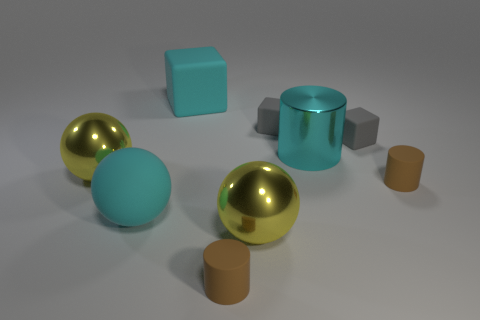The big cylinder has what color?
Offer a terse response. Cyan. There is a large cyan shiny object; are there any tiny brown rubber cylinders in front of it?
Offer a very short reply. Yes. There is a big block that is the same color as the large metallic cylinder; what is its material?
Your response must be concise. Rubber. Do the cyan sphere and the cyan metallic object that is in front of the large cube have the same size?
Provide a short and direct response. Yes. Is there a tiny object of the same color as the large cylinder?
Offer a very short reply. No. Are there any tiny gray objects that have the same shape as the cyan shiny object?
Your answer should be compact. No. The tiny thing that is in front of the big cyan cylinder and to the right of the cyan cylinder has what shape?
Ensure brevity in your answer.  Cylinder. How many other cyan balls are the same material as the cyan sphere?
Provide a succinct answer. 0. Are there fewer cyan objects right of the large shiny cylinder than cyan cylinders?
Provide a short and direct response. Yes. Are there any large cyan objects in front of the big cyan matte thing on the left side of the cyan cube?
Provide a short and direct response. No. 